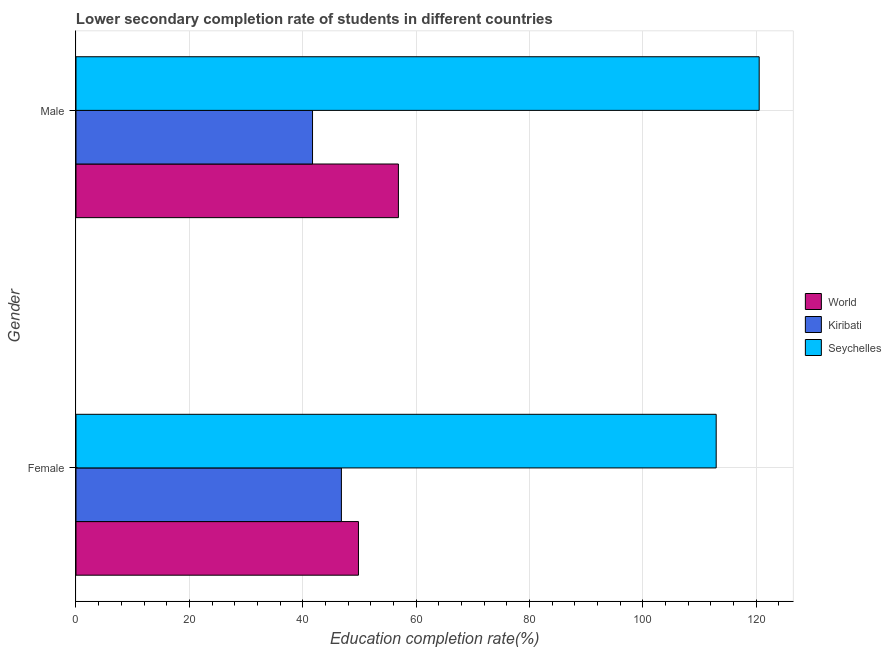How many different coloured bars are there?
Offer a very short reply. 3. How many groups of bars are there?
Your answer should be compact. 2. Are the number of bars on each tick of the Y-axis equal?
Keep it short and to the point. Yes. How many bars are there on the 2nd tick from the top?
Provide a succinct answer. 3. How many bars are there on the 1st tick from the bottom?
Offer a terse response. 3. What is the education completion rate of female students in Kiribati?
Provide a short and direct response. 46.83. Across all countries, what is the maximum education completion rate of male students?
Your answer should be compact. 120.54. Across all countries, what is the minimum education completion rate of female students?
Offer a very short reply. 46.83. In which country was the education completion rate of male students maximum?
Make the answer very short. Seychelles. In which country was the education completion rate of male students minimum?
Your response must be concise. Kiribati. What is the total education completion rate of female students in the graph?
Offer a terse response. 209.62. What is the difference between the education completion rate of male students in Seychelles and that in World?
Your response must be concise. 63.65. What is the difference between the education completion rate of male students in World and the education completion rate of female students in Seychelles?
Offer a terse response. -56.07. What is the average education completion rate of female students per country?
Your answer should be very brief. 69.87. What is the difference between the education completion rate of female students and education completion rate of male students in Kiribati?
Your answer should be compact. 5.1. In how many countries, is the education completion rate of male students greater than 68 %?
Keep it short and to the point. 1. What is the ratio of the education completion rate of male students in World to that in Seychelles?
Offer a terse response. 0.47. What does the 3rd bar from the top in Female represents?
Offer a very short reply. World. What does the 1st bar from the bottom in Male represents?
Your answer should be very brief. World. Are all the bars in the graph horizontal?
Your answer should be compact. Yes. How many countries are there in the graph?
Your answer should be compact. 3. What is the difference between two consecutive major ticks on the X-axis?
Keep it short and to the point. 20. Are the values on the major ticks of X-axis written in scientific E-notation?
Your answer should be compact. No. How are the legend labels stacked?
Offer a very short reply. Vertical. What is the title of the graph?
Provide a succinct answer. Lower secondary completion rate of students in different countries. Does "Sao Tome and Principe" appear as one of the legend labels in the graph?
Provide a succinct answer. No. What is the label or title of the X-axis?
Make the answer very short. Education completion rate(%). What is the Education completion rate(%) in World in Female?
Offer a terse response. 49.84. What is the Education completion rate(%) in Kiribati in Female?
Offer a terse response. 46.83. What is the Education completion rate(%) in Seychelles in Female?
Ensure brevity in your answer.  112.95. What is the Education completion rate(%) in World in Male?
Keep it short and to the point. 56.89. What is the Education completion rate(%) of Kiribati in Male?
Your response must be concise. 41.73. What is the Education completion rate(%) in Seychelles in Male?
Offer a terse response. 120.54. Across all Gender, what is the maximum Education completion rate(%) in World?
Give a very brief answer. 56.89. Across all Gender, what is the maximum Education completion rate(%) of Kiribati?
Your answer should be very brief. 46.83. Across all Gender, what is the maximum Education completion rate(%) of Seychelles?
Make the answer very short. 120.54. Across all Gender, what is the minimum Education completion rate(%) in World?
Provide a short and direct response. 49.84. Across all Gender, what is the minimum Education completion rate(%) in Kiribati?
Make the answer very short. 41.73. Across all Gender, what is the minimum Education completion rate(%) in Seychelles?
Ensure brevity in your answer.  112.95. What is the total Education completion rate(%) in World in the graph?
Make the answer very short. 106.72. What is the total Education completion rate(%) of Kiribati in the graph?
Your answer should be compact. 88.56. What is the total Education completion rate(%) in Seychelles in the graph?
Your response must be concise. 233.49. What is the difference between the Education completion rate(%) of World in Female and that in Male?
Your answer should be very brief. -7.05. What is the difference between the Education completion rate(%) of Kiribati in Female and that in Male?
Your answer should be very brief. 5.1. What is the difference between the Education completion rate(%) in Seychelles in Female and that in Male?
Give a very brief answer. -7.59. What is the difference between the Education completion rate(%) in World in Female and the Education completion rate(%) in Kiribati in Male?
Give a very brief answer. 8.1. What is the difference between the Education completion rate(%) of World in Female and the Education completion rate(%) of Seychelles in Male?
Your answer should be very brief. -70.7. What is the difference between the Education completion rate(%) of Kiribati in Female and the Education completion rate(%) of Seychelles in Male?
Provide a succinct answer. -73.71. What is the average Education completion rate(%) of World per Gender?
Your response must be concise. 53.36. What is the average Education completion rate(%) in Kiribati per Gender?
Keep it short and to the point. 44.28. What is the average Education completion rate(%) of Seychelles per Gender?
Ensure brevity in your answer.  116.75. What is the difference between the Education completion rate(%) of World and Education completion rate(%) of Kiribati in Female?
Keep it short and to the point. 3.01. What is the difference between the Education completion rate(%) of World and Education completion rate(%) of Seychelles in Female?
Keep it short and to the point. -63.12. What is the difference between the Education completion rate(%) of Kiribati and Education completion rate(%) of Seychelles in Female?
Your answer should be very brief. -66.12. What is the difference between the Education completion rate(%) in World and Education completion rate(%) in Kiribati in Male?
Your answer should be very brief. 15.15. What is the difference between the Education completion rate(%) of World and Education completion rate(%) of Seychelles in Male?
Provide a succinct answer. -63.65. What is the difference between the Education completion rate(%) of Kiribati and Education completion rate(%) of Seychelles in Male?
Provide a succinct answer. -78.81. What is the ratio of the Education completion rate(%) in World in Female to that in Male?
Give a very brief answer. 0.88. What is the ratio of the Education completion rate(%) of Kiribati in Female to that in Male?
Provide a short and direct response. 1.12. What is the ratio of the Education completion rate(%) in Seychelles in Female to that in Male?
Ensure brevity in your answer.  0.94. What is the difference between the highest and the second highest Education completion rate(%) in World?
Give a very brief answer. 7.05. What is the difference between the highest and the second highest Education completion rate(%) in Kiribati?
Your answer should be very brief. 5.1. What is the difference between the highest and the second highest Education completion rate(%) in Seychelles?
Offer a terse response. 7.59. What is the difference between the highest and the lowest Education completion rate(%) in World?
Your answer should be compact. 7.05. What is the difference between the highest and the lowest Education completion rate(%) in Kiribati?
Offer a terse response. 5.1. What is the difference between the highest and the lowest Education completion rate(%) in Seychelles?
Give a very brief answer. 7.59. 